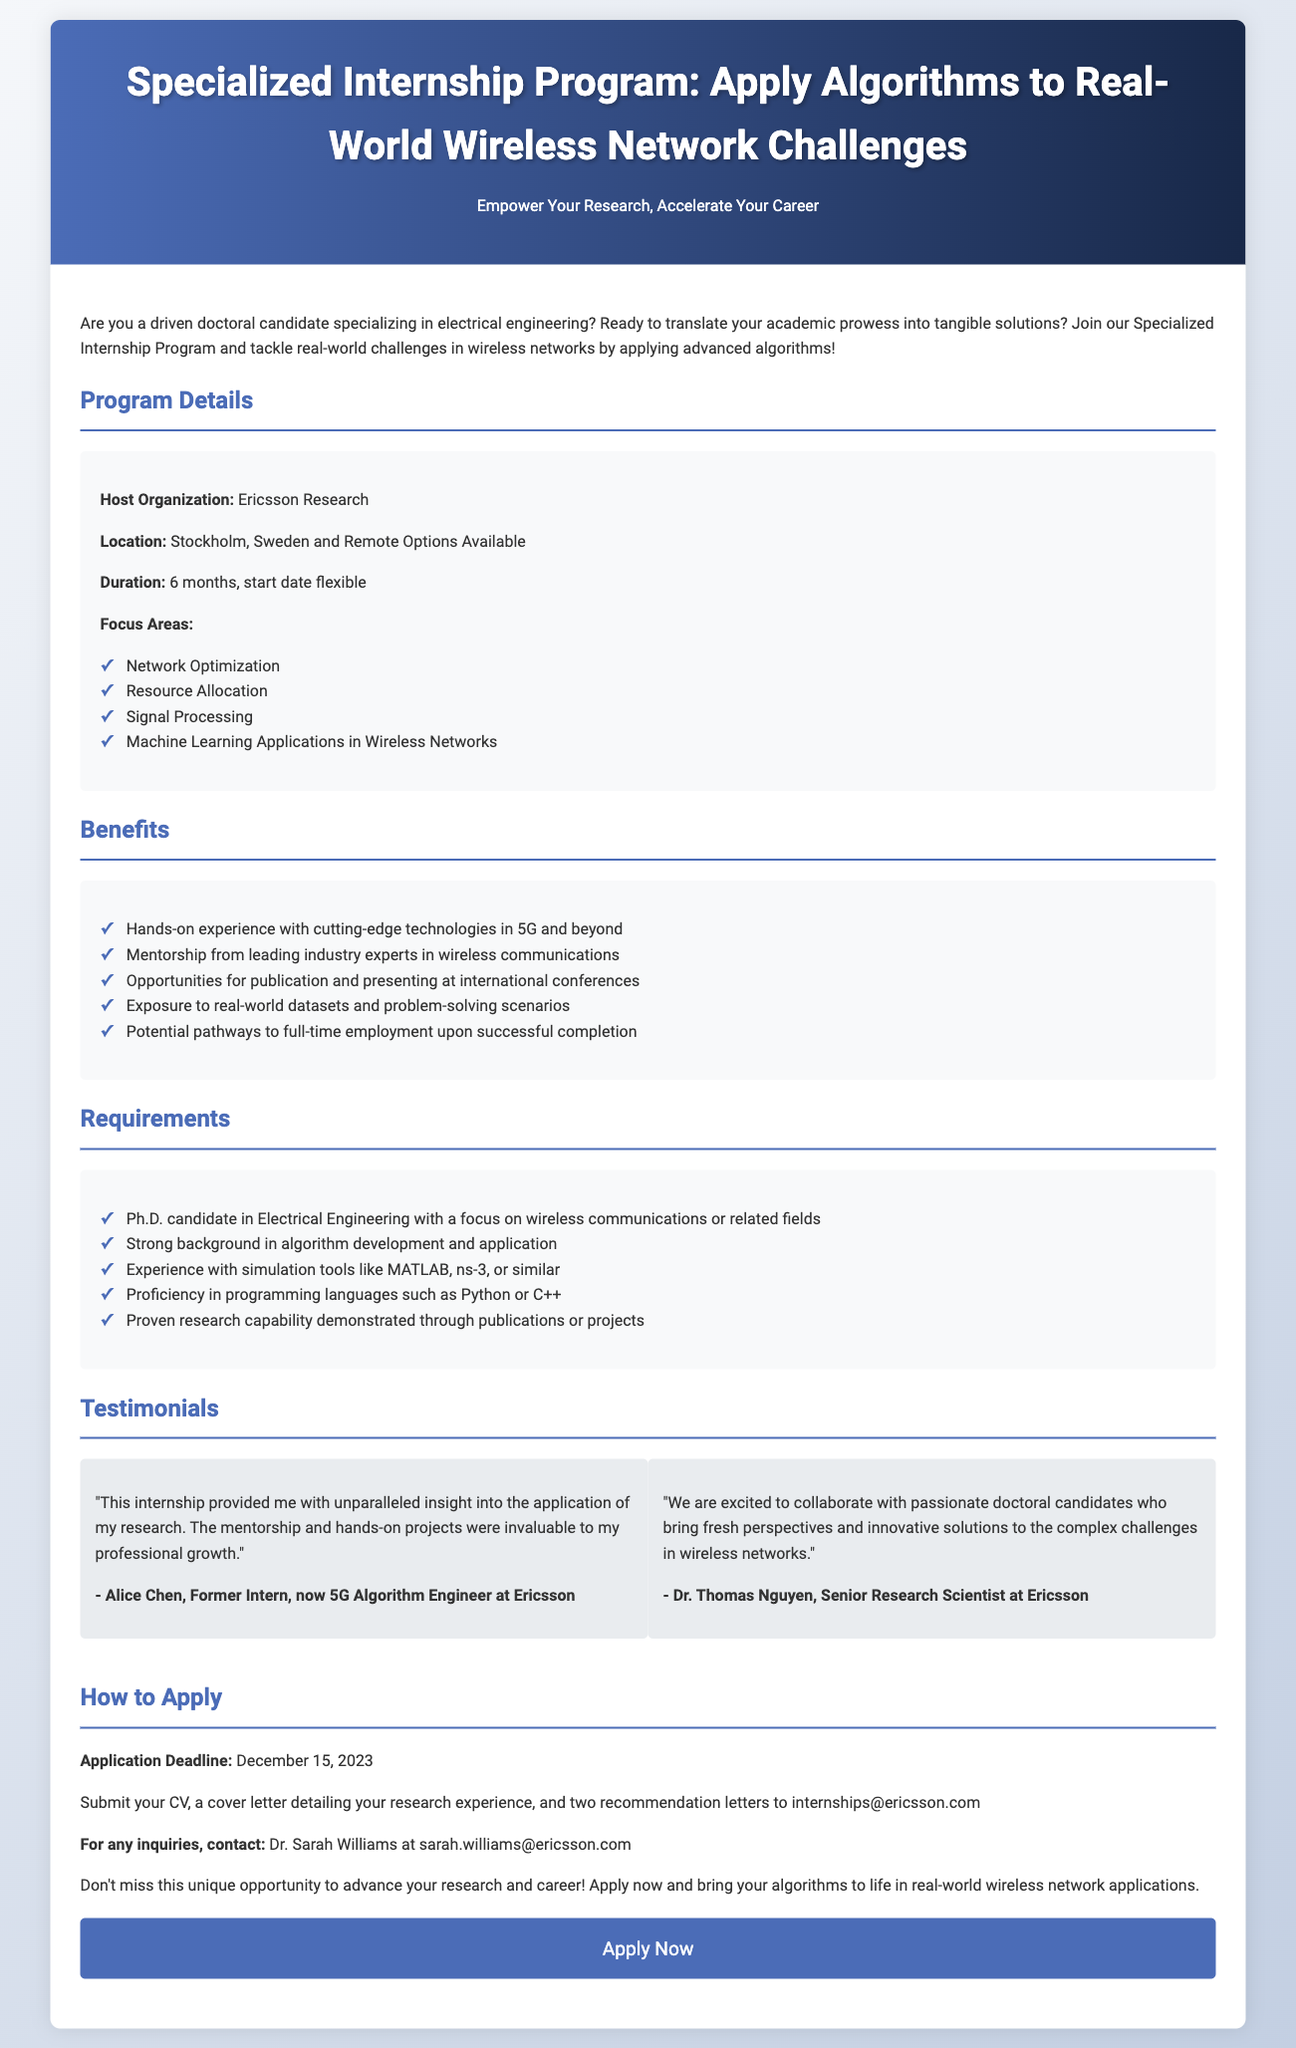What is the host organization? The document states that the host organization for the internship program is Ericsson Research.
Answer: Ericsson Research What is the location of the internship? According to the document, the internship can take place in Stockholm, Sweden or have remote options available.
Answer: Stockholm, Sweden and Remote Options Available What is the duration of the internship? The document specifies that the duration of the internship is 6 months, with a flexible start date.
Answer: 6 months What is the application deadline? The document states the application deadline is December 15, 2023.
Answer: December 15, 2023 What type of candidates are required? The document mentions that Ph.D. candidates in Electrical Engineering focusing on wireless communications or related fields are sought after.
Answer: Ph.D. candidate in Electrical Engineering What is one of the focus areas of the internship? The document lists network optimization as one of the focus areas for the internship program.
Answer: Network Optimization What experience is preferred for the candidates? According to the document, candidates should have experience with simulation tools like MATLAB, ns-3, or similar.
Answer: Simulation tools like MATLAB, ns-3, or similar What is one of the benefits mentioned for interns? The document mentions that interns will gain hands-on experience with cutting-edge technologies in 5G and beyond.
Answer: Hands-on experience with cutting-edge technologies in 5G and beyond What is required for application submission? The document specifies that applicants must submit their CV, a cover letter, and two recommendation letters.
Answer: CV, cover letter, and two recommendation letters 